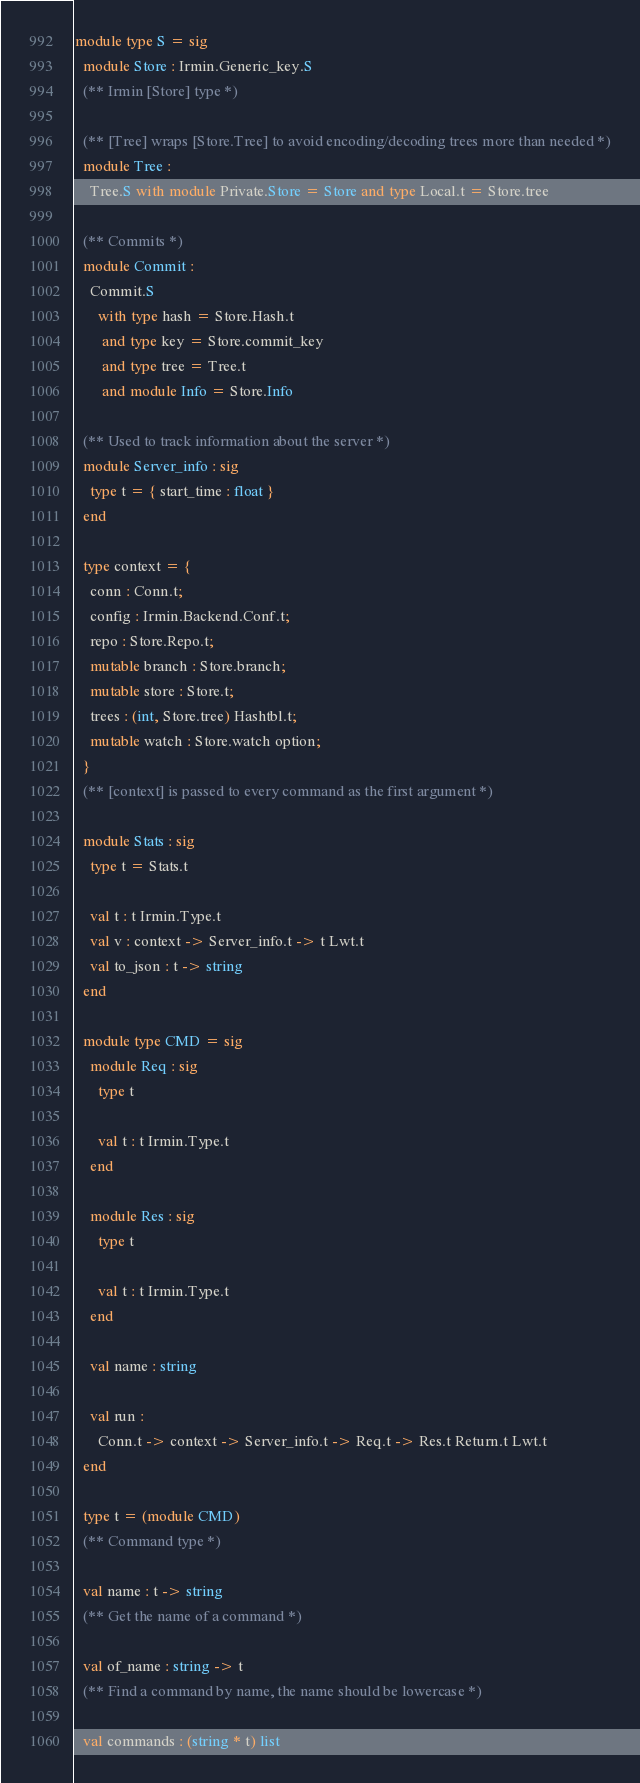<code> <loc_0><loc_0><loc_500><loc_500><_OCaml_>module type S = sig
  module Store : Irmin.Generic_key.S
  (** Irmin [Store] type *)

  (** [Tree] wraps [Store.Tree] to avoid encoding/decoding trees more than needed *)
  module Tree :
    Tree.S with module Private.Store = Store and type Local.t = Store.tree

  (** Commits *)
  module Commit :
    Commit.S
      with type hash = Store.Hash.t
       and type key = Store.commit_key
       and type tree = Tree.t
       and module Info = Store.Info

  (** Used to track information about the server *)
  module Server_info : sig
    type t = { start_time : float }
  end

  type context = {
    conn : Conn.t;
    config : Irmin.Backend.Conf.t;
    repo : Store.Repo.t;
    mutable branch : Store.branch;
    mutable store : Store.t;
    trees : (int, Store.tree) Hashtbl.t;
    mutable watch : Store.watch option;
  }
  (** [context] is passed to every command as the first argument *)

  module Stats : sig
    type t = Stats.t

    val t : t Irmin.Type.t
    val v : context -> Server_info.t -> t Lwt.t
    val to_json : t -> string
  end

  module type CMD = sig
    module Req : sig
      type t

      val t : t Irmin.Type.t
    end

    module Res : sig
      type t

      val t : t Irmin.Type.t
    end

    val name : string

    val run :
      Conn.t -> context -> Server_info.t -> Req.t -> Res.t Return.t Lwt.t
  end

  type t = (module CMD)
  (** Command type *)

  val name : t -> string
  (** Get the name of a command *)

  val of_name : string -> t
  (** Find a command by name, the name should be lowercase *)

  val commands : (string * t) list</code> 